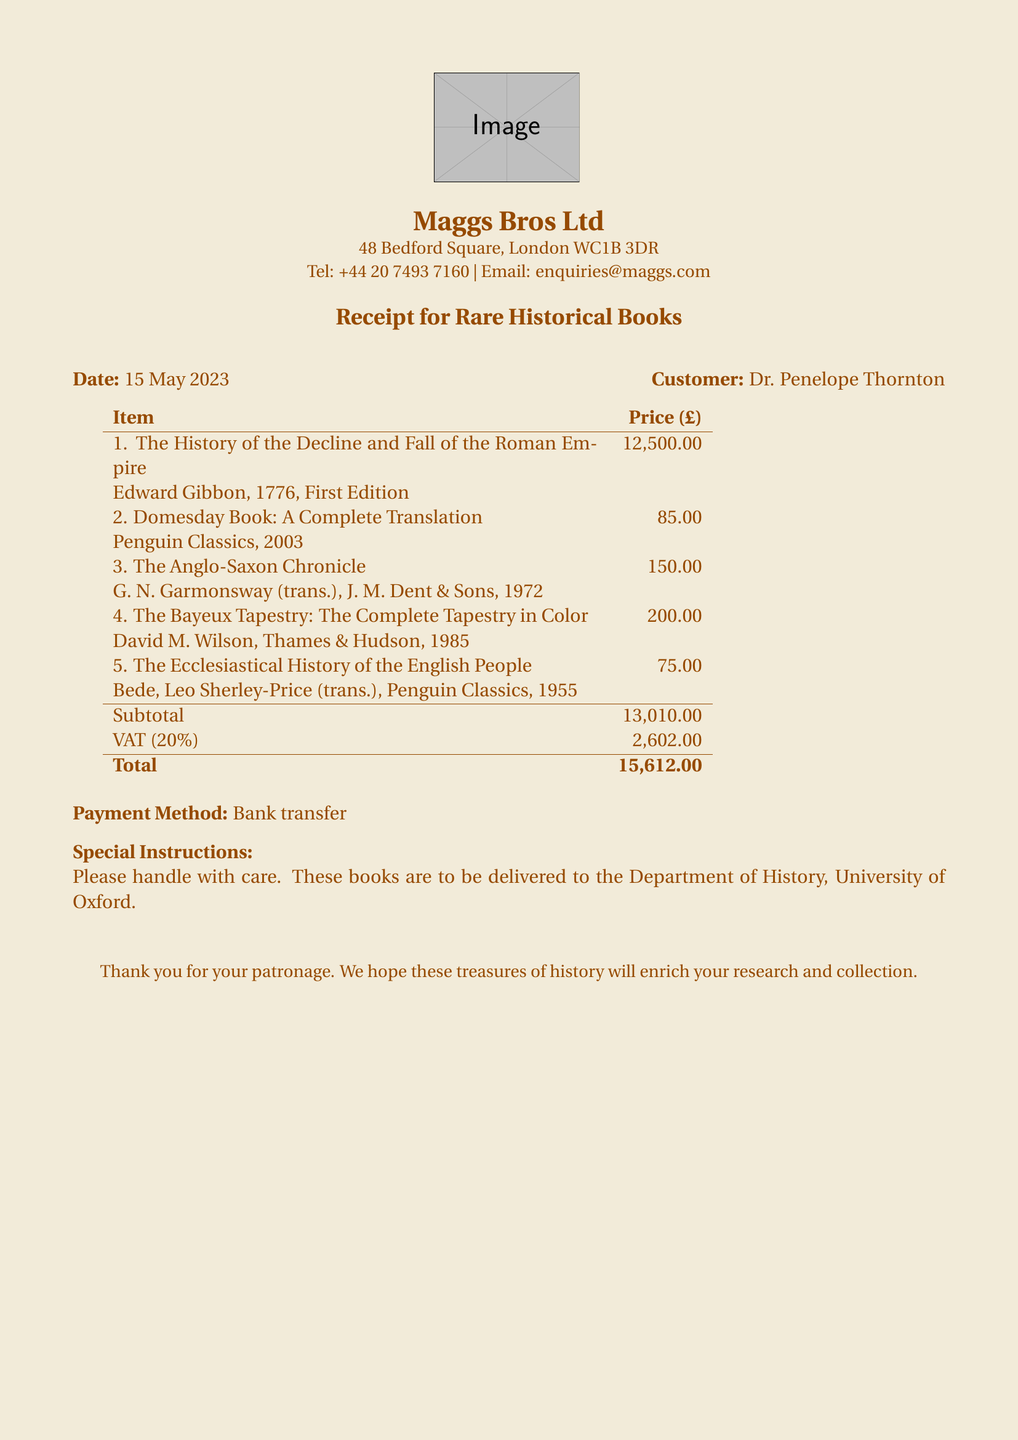What is the name of the bookshop? The name of the bookshop is listed at the top of the document.
Answer: Maggs Bros Ltd What is the date of the transaction? The transaction date is specified prominently in the document.
Answer: 15 May 2023 Who is the customer? The customer's name is provided near the date of the transaction.
Answer: Dr. Penelope Thornton What is the total amount due? The total amount is calculated based on the subtotal and VAT in the document.
Answer: 15,612.00 How many books were purchased? The number of items in the transaction can be counted from the list provided in the document.
Answer: 5 What is the price of "The History of the Decline and Fall of the Roman Empire"? The price is specified next to the title in the item list.
Answer: 12,500.00 What special instructions are given for the delivery? Special instructions are included towards the end of the document.
Answer: Please handle with care. These books are to be delivered to the Department of History, University of Oxford What payment method was used? The payment method is listed in the section detailing payment information.
Answer: Bank transfer What is the VAT percentage applied? The VAT percentage is mentioned explicitly in the subtotal and total calculation section.
Answer: 20% 